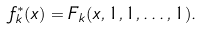<formula> <loc_0><loc_0><loc_500><loc_500>f _ { k } ^ { * } ( x ) = F _ { k } ( x , 1 , 1 , \dots , 1 ) .</formula> 